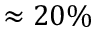<formula> <loc_0><loc_0><loc_500><loc_500>\approx 2 0 \%</formula> 